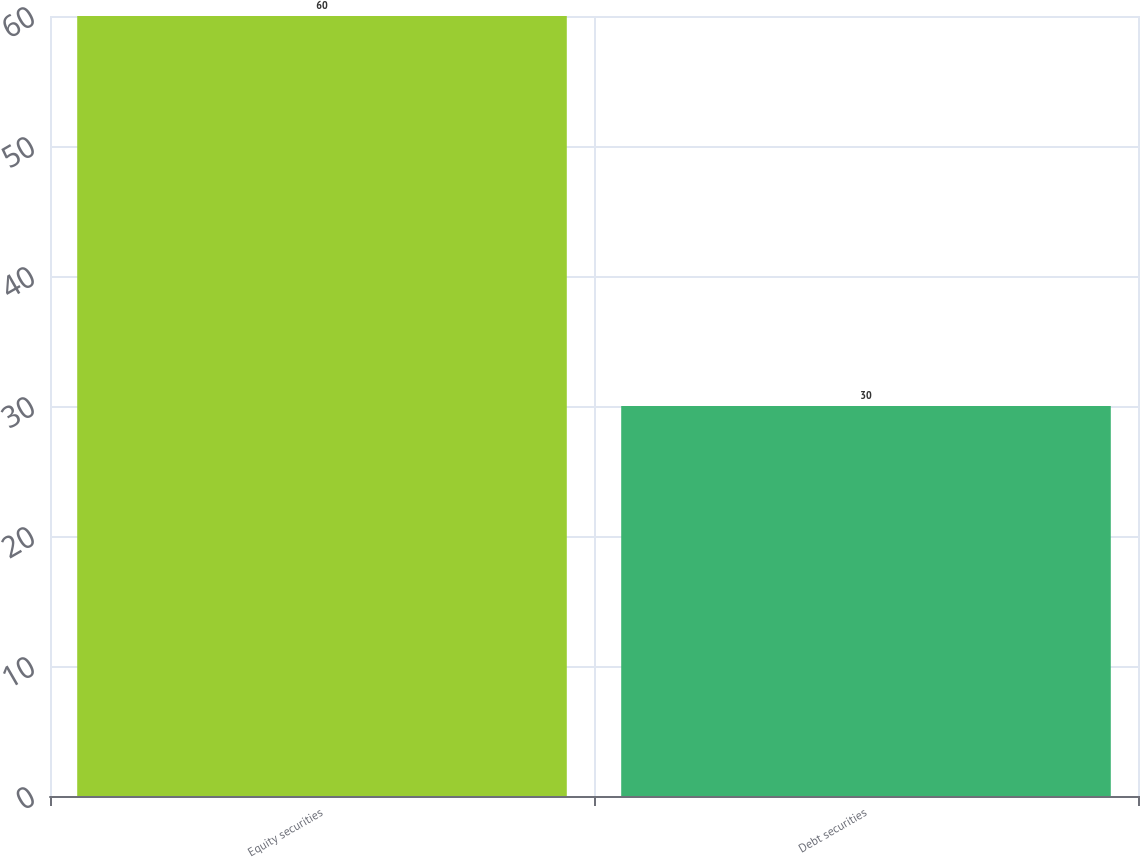Convert chart. <chart><loc_0><loc_0><loc_500><loc_500><bar_chart><fcel>Equity securities<fcel>Debt securities<nl><fcel>60<fcel>30<nl></chart> 